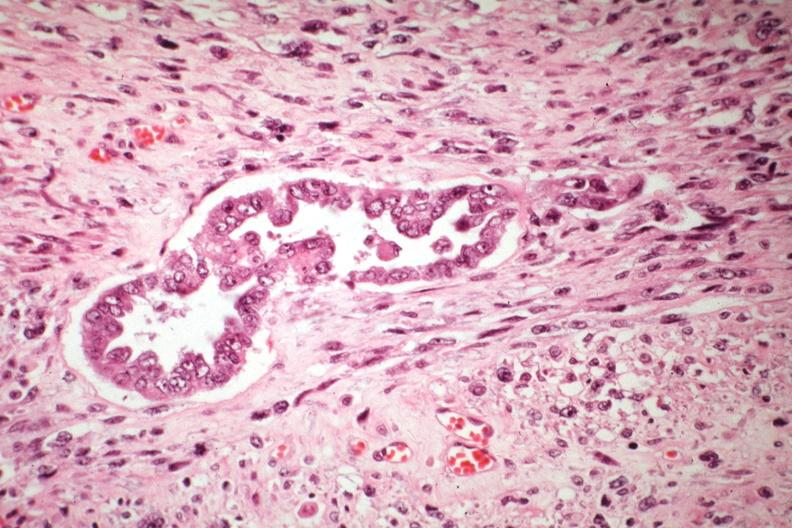s uterus present?
Answer the question using a single word or phrase. Yes 